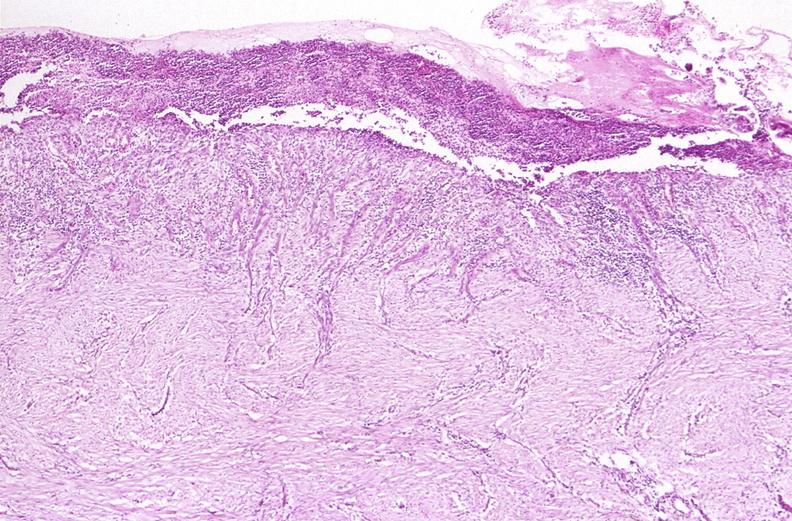what is present?
Answer the question using a single word or phrase. Gastrointestinal 